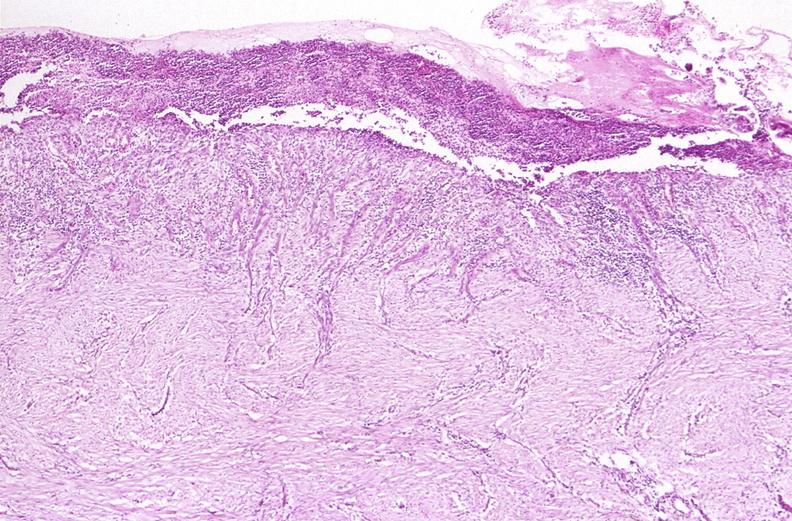what is present?
Answer the question using a single word or phrase. Gastrointestinal 